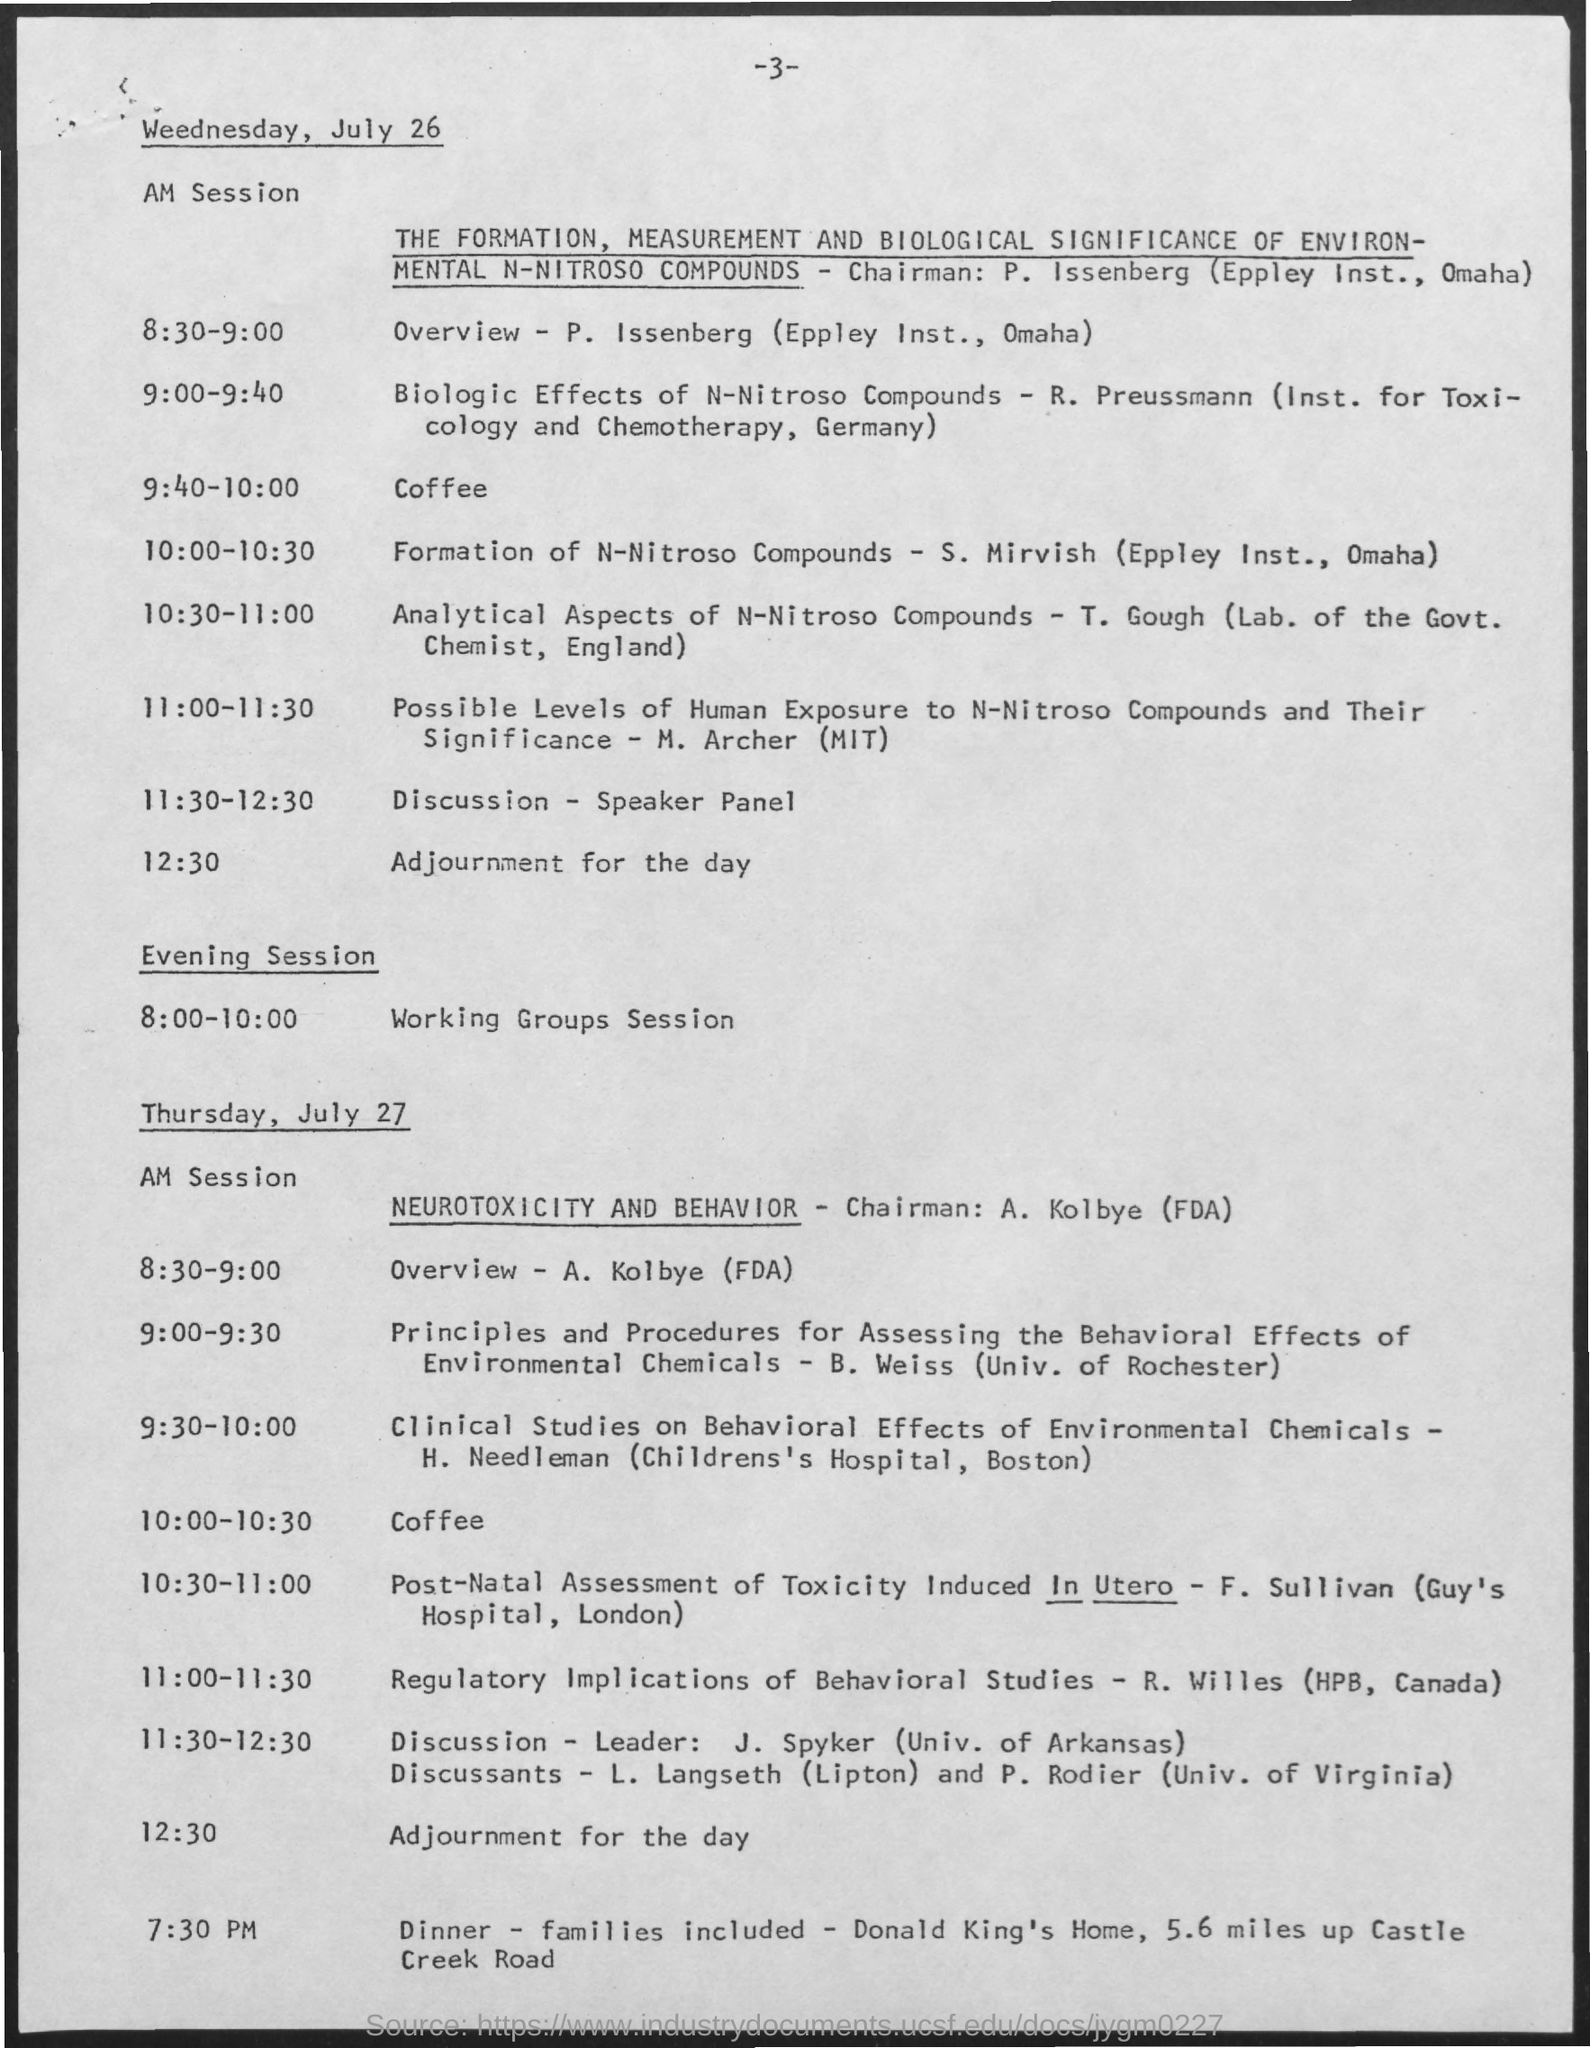Give some essential details in this illustration. The adjournment for the day on Wednesday, July 26, is at 12:30. The Discussion-Speaker Panel will take place on Wednesday, July 26 from 11:30 a.m. to 12:30 p.m. The coffee will be held on Wednesday, July 26, from 9:40 to 10:00. 